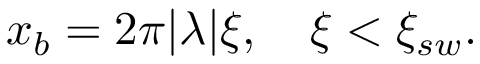<formula> <loc_0><loc_0><loc_500><loc_500>\begin{array} { r } { x _ { b } = 2 \pi | \lambda | \xi , \xi < \xi _ { s w } . } \end{array}</formula> 